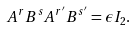<formula> <loc_0><loc_0><loc_500><loc_500>A ^ { r } B ^ { s } A ^ { r ^ { \prime } } B ^ { s ^ { \prime } } = \epsilon { I } _ { 2 } .</formula> 